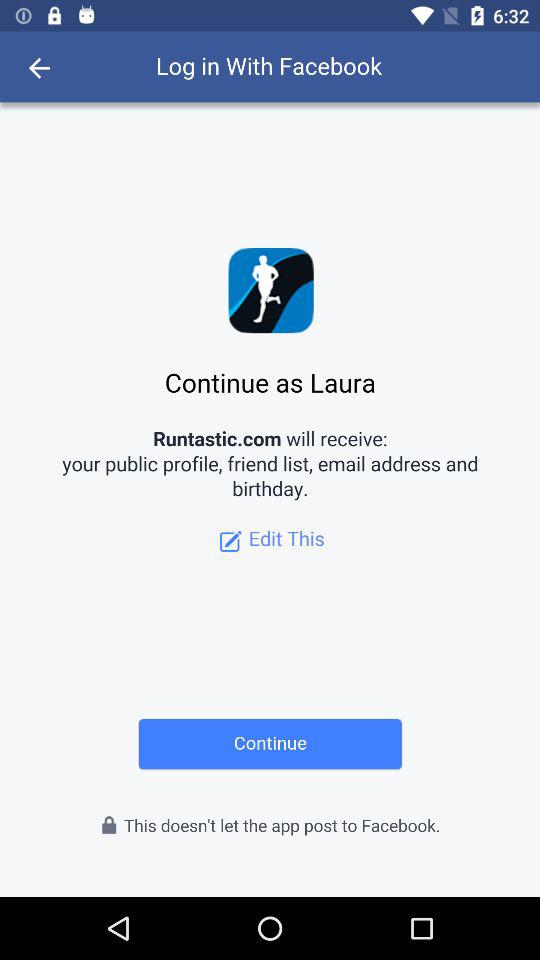What is the user name? The user name is Laura. 